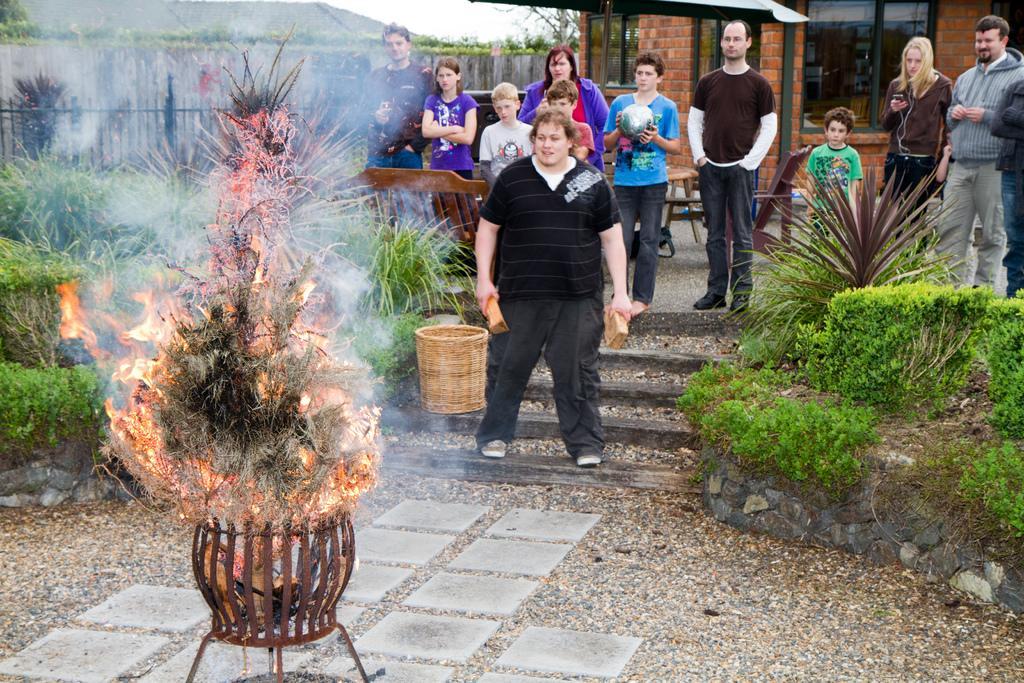How would you summarize this image in a sentence or two? In this image, there is an outside view. There are some persons wearing clothes and standing in front of the fire. There is a person in the middle of the image holding bricks with his hands. There is a basket in the middle of the image. There are some plants on the right and on the left side of the image. There is a house in the top right of the image. There is a fencing in the top left of the image. 